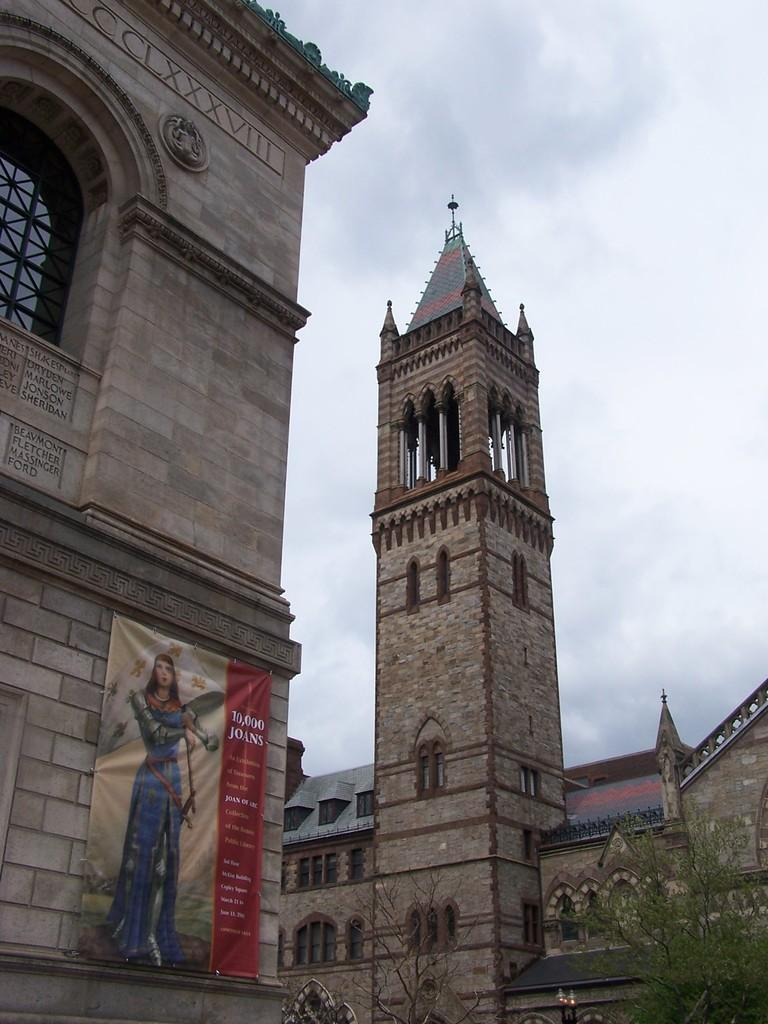What type of structures can be seen in the image? There are buildings, a tower, and pillars in the image. What architectural features are present in the buildings? There are glass windows in the image. What additional element is present in the image? There is a banner in the image. What type of vegetation can be seen in the image? There are trees in the image. What lighting elements are present in the image? There are lights in the image. What can be seen in the background of the image? The sky is visible in the background of the image. What is the weight of the pigs seen in the image? There are no pigs present in the image, so their weight cannot be determined. Is there a slope visible in the image? There is no slope visible in the image; it features buildings, a tower, pillars, and other elements. 